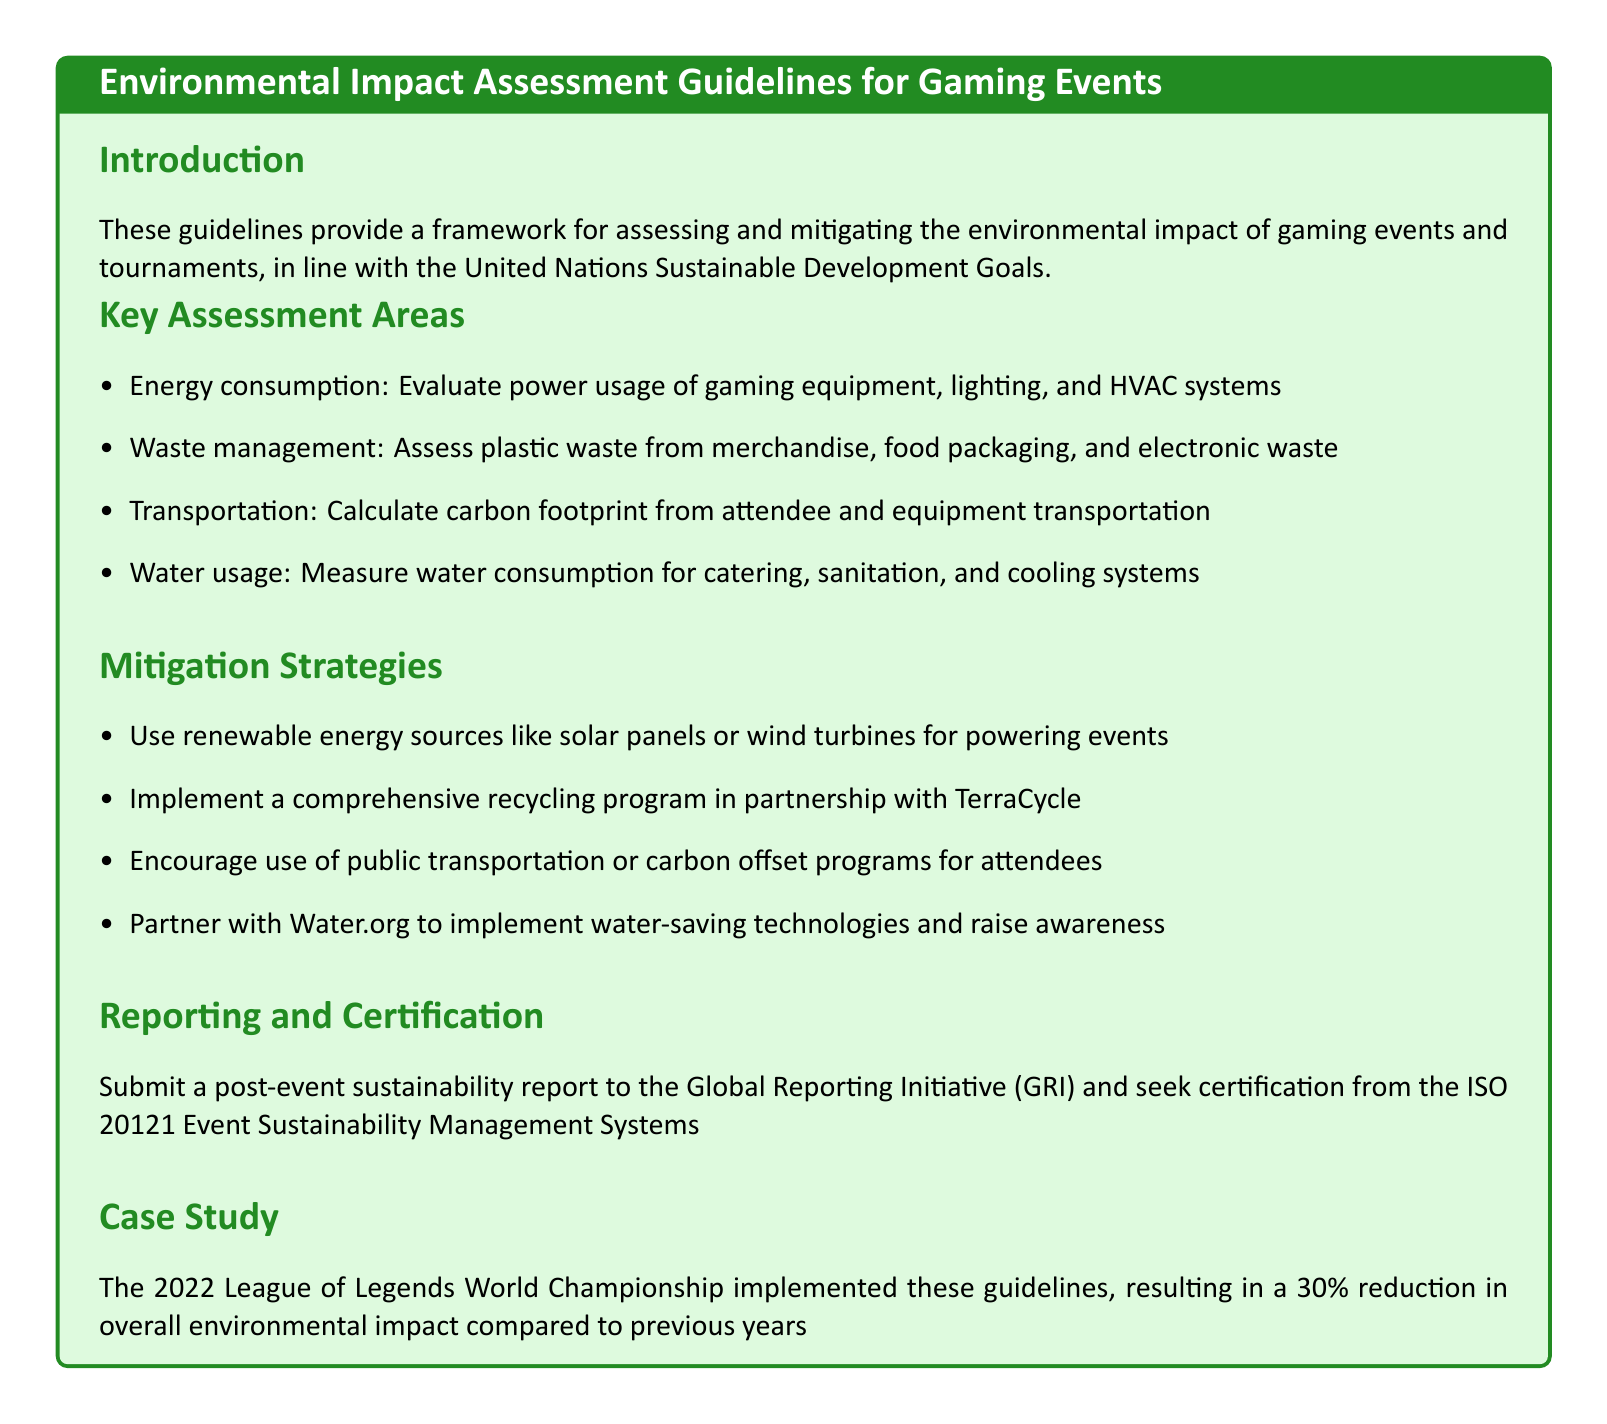What is the primary goal of the guidelines? The guidelines aim to provide a framework for assessing and mitigating the environmental impact of gaming events and tournaments, aligning with the United Nations Sustainable Development Goals.
Answer: framework for assessing and mitigating environmental impact What year was the case study about the League of Legends World Championship conducted? The document specifies that the case study is from the year 2022.
Answer: 2022 What percentage reduction in overall environmental impact was achieved in the case study? The document reports a 30% reduction in overall environmental impact compared to previous years.
Answer: 30% What organization should the post-event sustainability report be submitted to? The guidelines specify that the report should be submitted to the Global Reporting Initiative (GRI).
Answer: Global Reporting Initiative Which renewable energy sources are suggested for powering events? The guidelines recommend using solar panels or wind turbines as renewable energy sources.
Answer: solar panels or wind turbines How many key assessment areas are detailed in the guidelines? The document outlines four key assessment areas related to environmental impact.
Answer: four What does the document suggest partnering with for recycling programs? The guidelines mention partnering with TerraCycle for implementing a comprehensive recycling program.
Answer: TerraCycle Which water-saving organization is recommended for partnership? The document suggests partnering with Water.org to implement water-saving technologies.
Answer: Water.org 